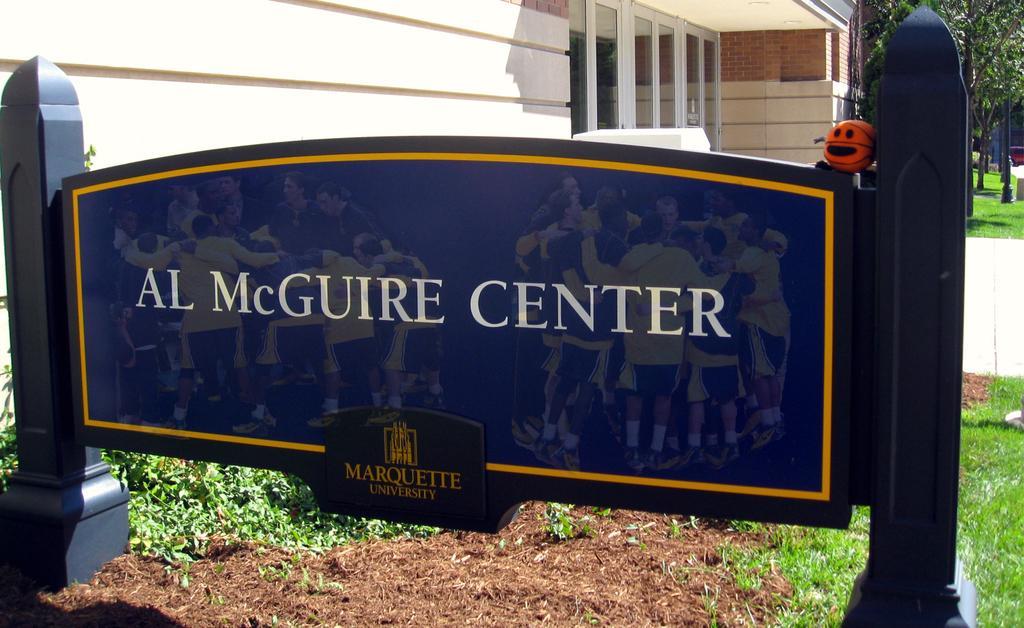In one or two sentences, can you explain what this image depicts? In this picture we can see a board in the front, there is some text on the board, at the bottom there is grass, we can see a house in the middle, in the background there are some trees and grass. 